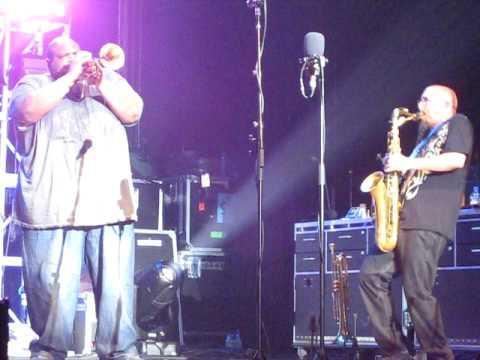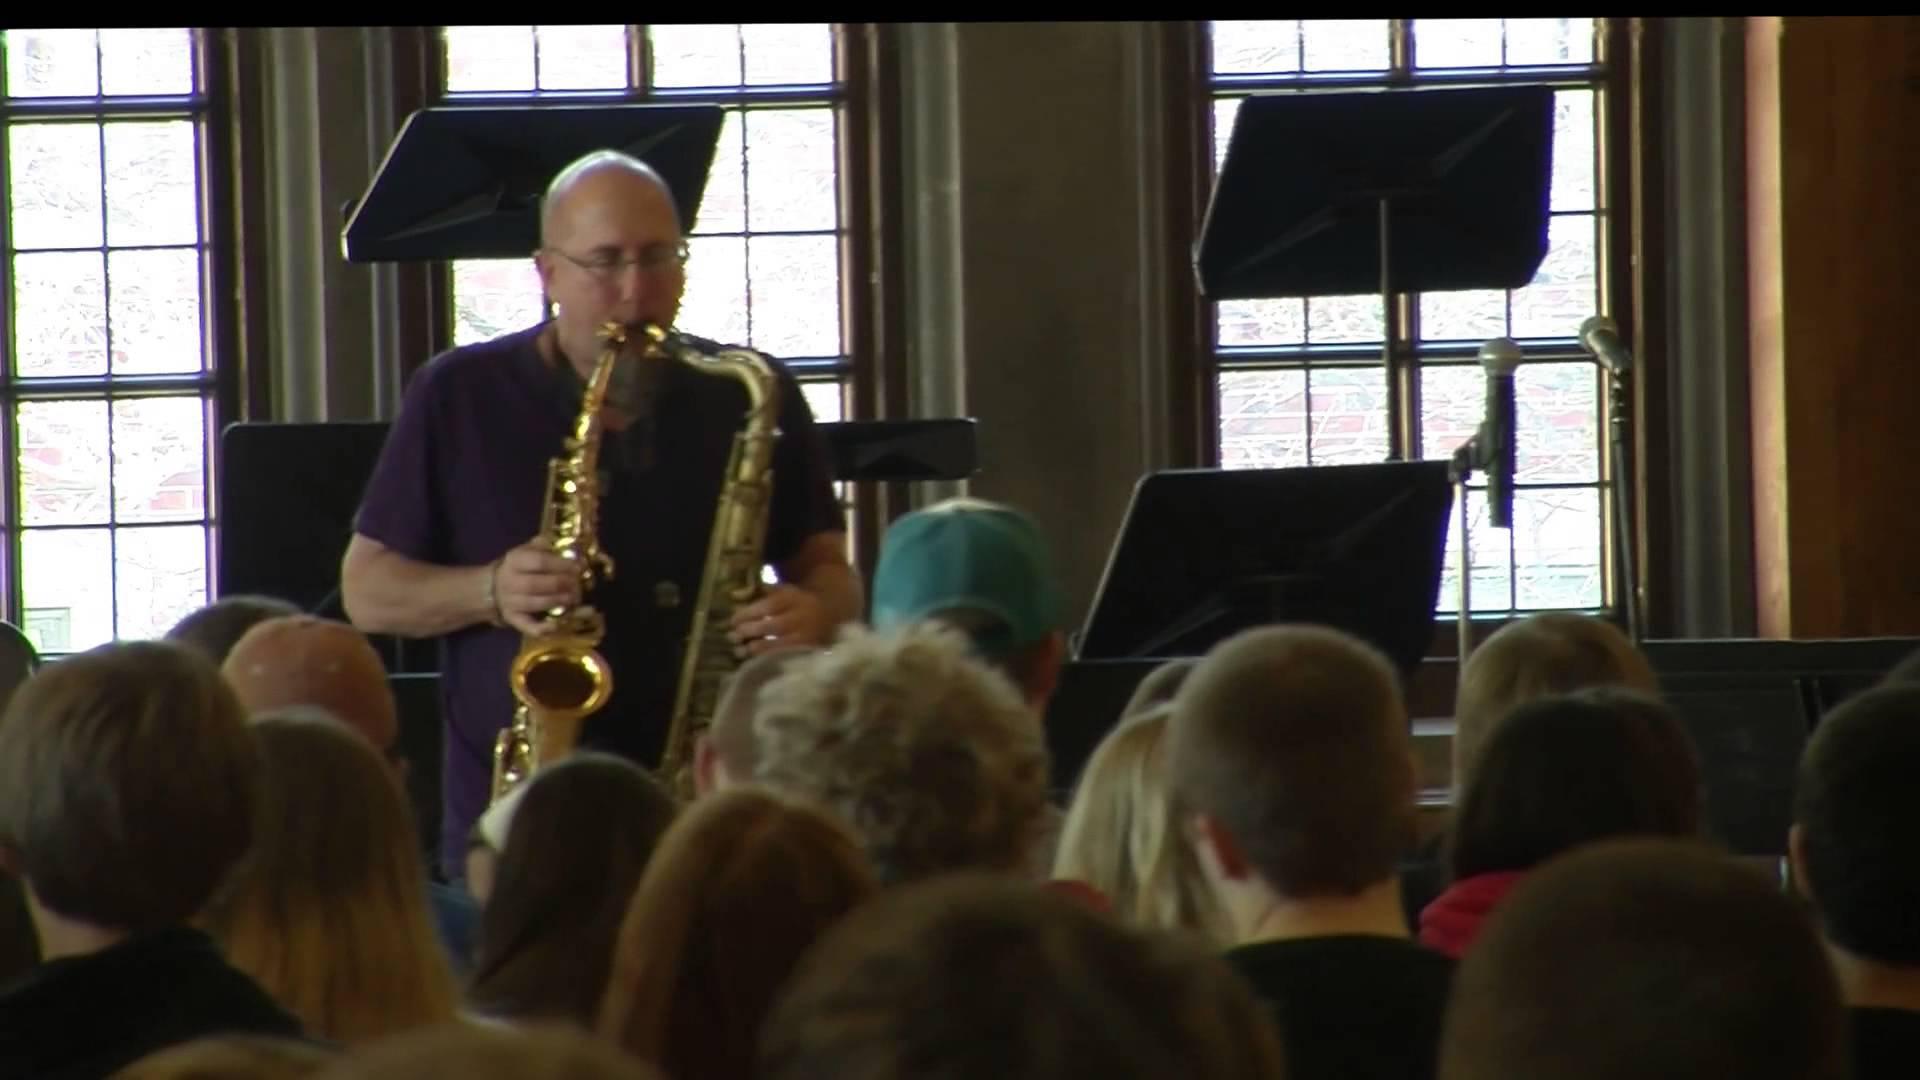The first image is the image on the left, the second image is the image on the right. Evaluate the accuracy of this statement regarding the images: "The musician in the image on the left is playing two saxes.". Is it true? Answer yes or no. No. The first image is the image on the left, the second image is the image on the right. Considering the images on both sides, is "Left image shows a man simultaneously playing two brass instruments, and the right image does not." valid? Answer yes or no. No. 